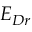<formula> <loc_0><loc_0><loc_500><loc_500>E _ { D r }</formula> 